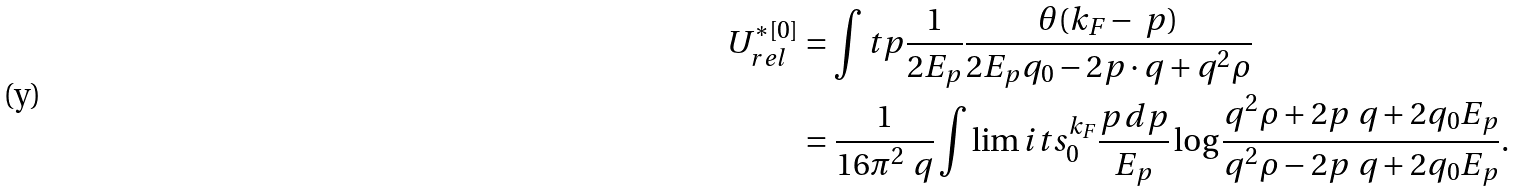Convert formula to latex. <formula><loc_0><loc_0><loc_500><loc_500>U ^ { * [ 0 ] } _ { r e l } & = \int t { p } \frac { 1 } { 2 E _ { p } } \frac { \theta ( k _ { F } - \ p ) } { 2 E _ { p } q _ { 0 } - 2 { p } \cdot { q } + q ^ { 2 } \rho } \\ & = \frac { 1 } { 1 6 \pi ^ { 2 } \ q } \int \lim i t s _ { 0 } ^ { k _ { F } } \frac { p \, d p } { E _ { p } } \log \frac { q ^ { 2 } \rho + 2 p \ q + 2 q _ { 0 } E _ { p } } { q ^ { 2 } \rho - 2 p \ q + 2 q _ { 0 } E _ { p } } .</formula> 